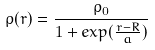<formula> <loc_0><loc_0><loc_500><loc_500>\rho ( r ) = \frac { \rho _ { 0 } } { 1 + e x p ( \frac { r - R } { a } ) }</formula> 